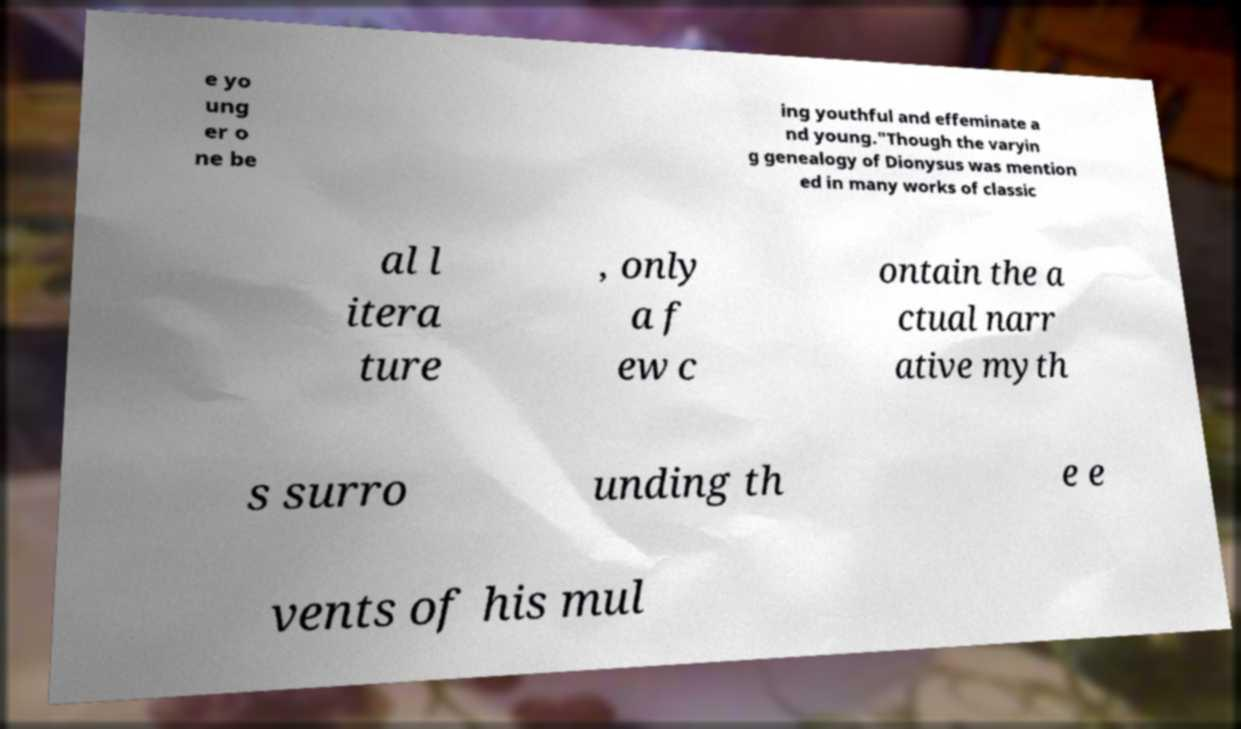Please read and relay the text visible in this image. What does it say? e yo ung er o ne be ing youthful and effeminate a nd young."Though the varyin g genealogy of Dionysus was mention ed in many works of classic al l itera ture , only a f ew c ontain the a ctual narr ative myth s surro unding th e e vents of his mul 